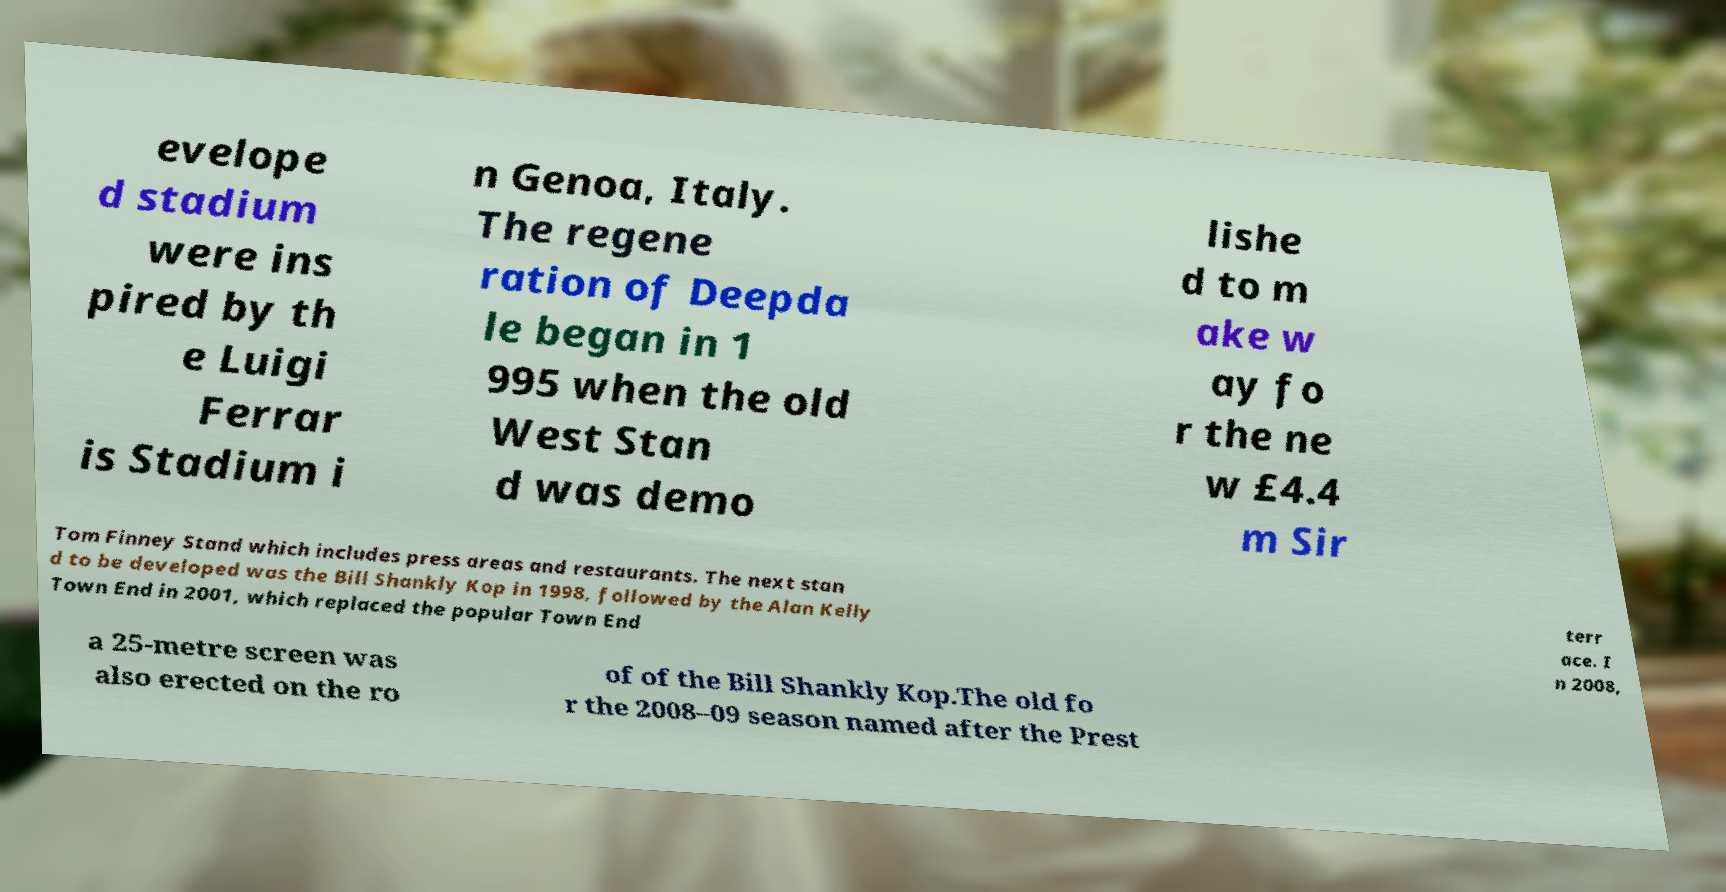I need the written content from this picture converted into text. Can you do that? evelope d stadium were ins pired by th e Luigi Ferrar is Stadium i n Genoa, Italy. The regene ration of Deepda le began in 1 995 when the old West Stan d was demo lishe d to m ake w ay fo r the ne w £4.4 m Sir Tom Finney Stand which includes press areas and restaurants. The next stan d to be developed was the Bill Shankly Kop in 1998, followed by the Alan Kelly Town End in 2001, which replaced the popular Town End terr ace. I n 2008, a 25-metre screen was also erected on the ro of of the Bill Shankly Kop.The old fo r the 2008–09 season named after the Prest 